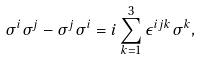<formula> <loc_0><loc_0><loc_500><loc_500>\sigma ^ { i } \sigma ^ { j } - \sigma ^ { j } \sigma ^ { i } = i \sum _ { k = 1 } ^ { 3 } \epsilon ^ { i j k } \sigma ^ { k } ,</formula> 